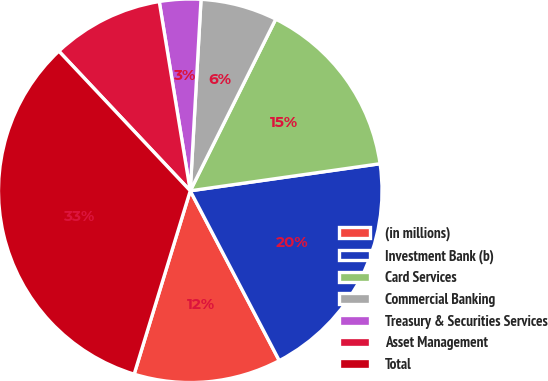Convert chart to OTSL. <chart><loc_0><loc_0><loc_500><loc_500><pie_chart><fcel>(in millions)<fcel>Investment Bank (b)<fcel>Card Services<fcel>Commercial Banking<fcel>Treasury & Securities Services<fcel>Asset Management<fcel>Total<nl><fcel>12.41%<fcel>19.57%<fcel>15.39%<fcel>6.46%<fcel>3.48%<fcel>9.43%<fcel>33.26%<nl></chart> 